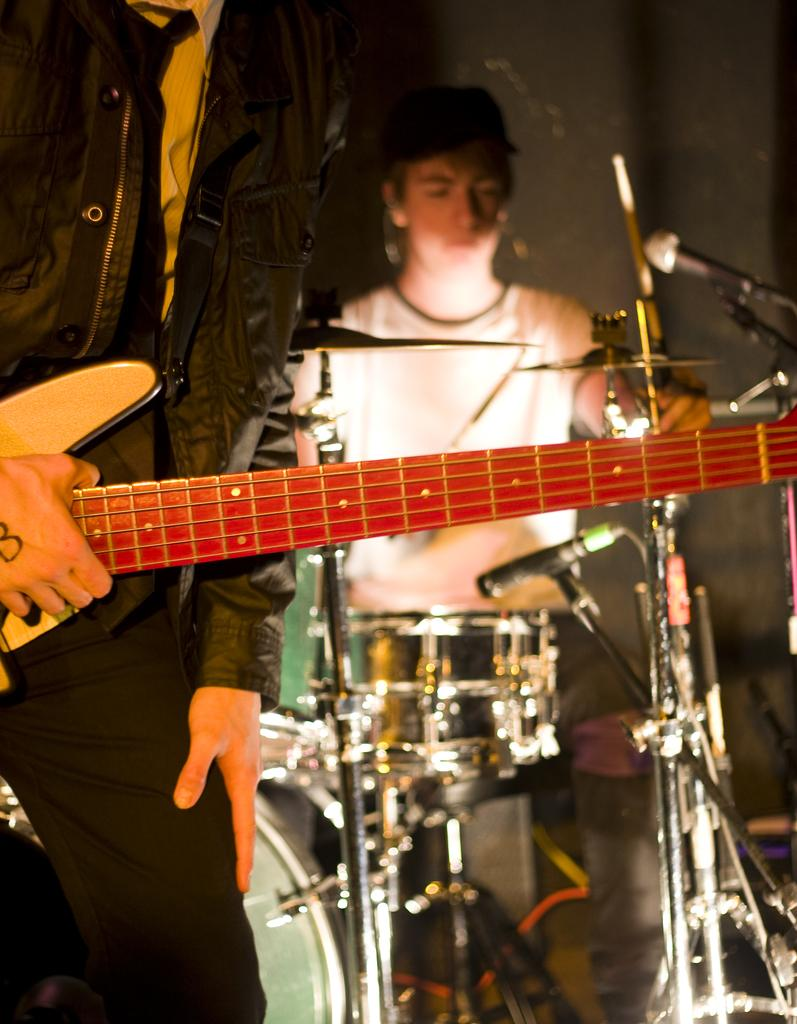What is the person on the left side of the image doing? The person on the left side of the image is holding a guitar. What is the person on the right side of the image doing? The person on the right side of the image is playing drums. What object is present for amplifying sound in the image? There is a microphone (mike) in the image. What can be seen in the background of the image? There is a wall in the background of the image. What type of hen is sitting on the microphone in the image? There is no hen present in the image; it features two people playing musical instruments and a microphone. 